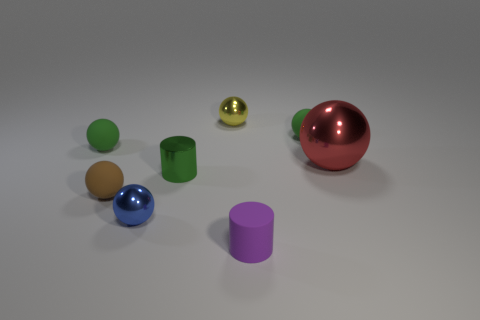Subtract all red spheres. How many spheres are left? 5 Subtract all brown rubber spheres. How many spheres are left? 5 Subtract all cyan balls. Subtract all gray cubes. How many balls are left? 6 Add 1 purple things. How many objects exist? 9 Subtract all balls. How many objects are left? 2 Add 3 small purple rubber objects. How many small purple rubber objects are left? 4 Add 4 tiny green rubber balls. How many tiny green rubber balls exist? 6 Subtract 0 gray cubes. How many objects are left? 8 Subtract all yellow balls. Subtract all small cyan cylinders. How many objects are left? 7 